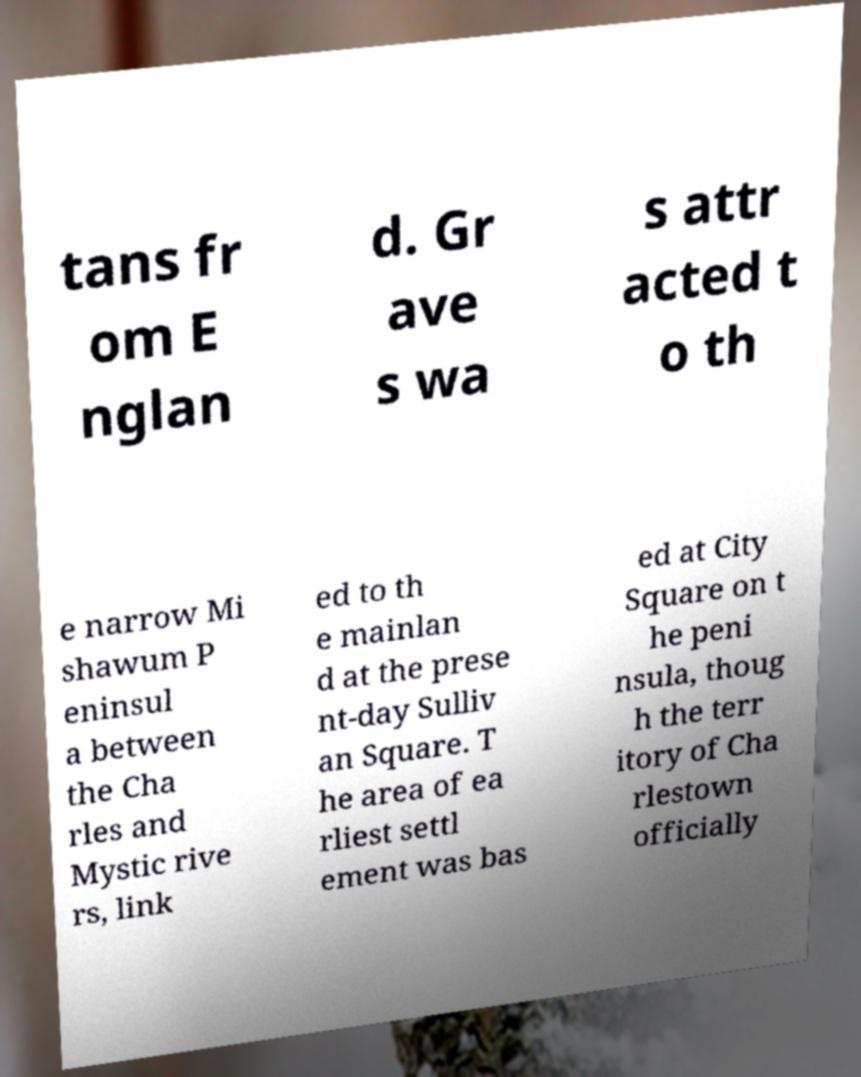Please identify and transcribe the text found in this image. tans fr om E nglan d. Gr ave s wa s attr acted t o th e narrow Mi shawum P eninsul a between the Cha rles and Mystic rive rs, link ed to th e mainlan d at the prese nt-day Sulliv an Square. T he area of ea rliest settl ement was bas ed at City Square on t he peni nsula, thoug h the terr itory of Cha rlestown officially 